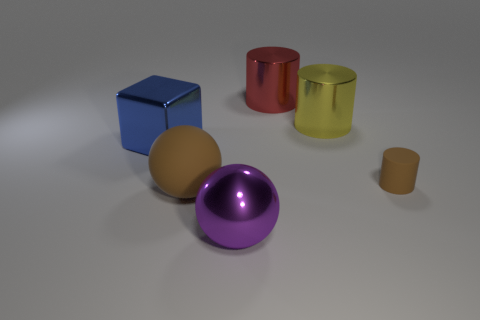Can you tell me the colors of the objects that are spheres? Certainly! In the image, there are two spherical objects: one is yellow and the other is a vibrant purple. 